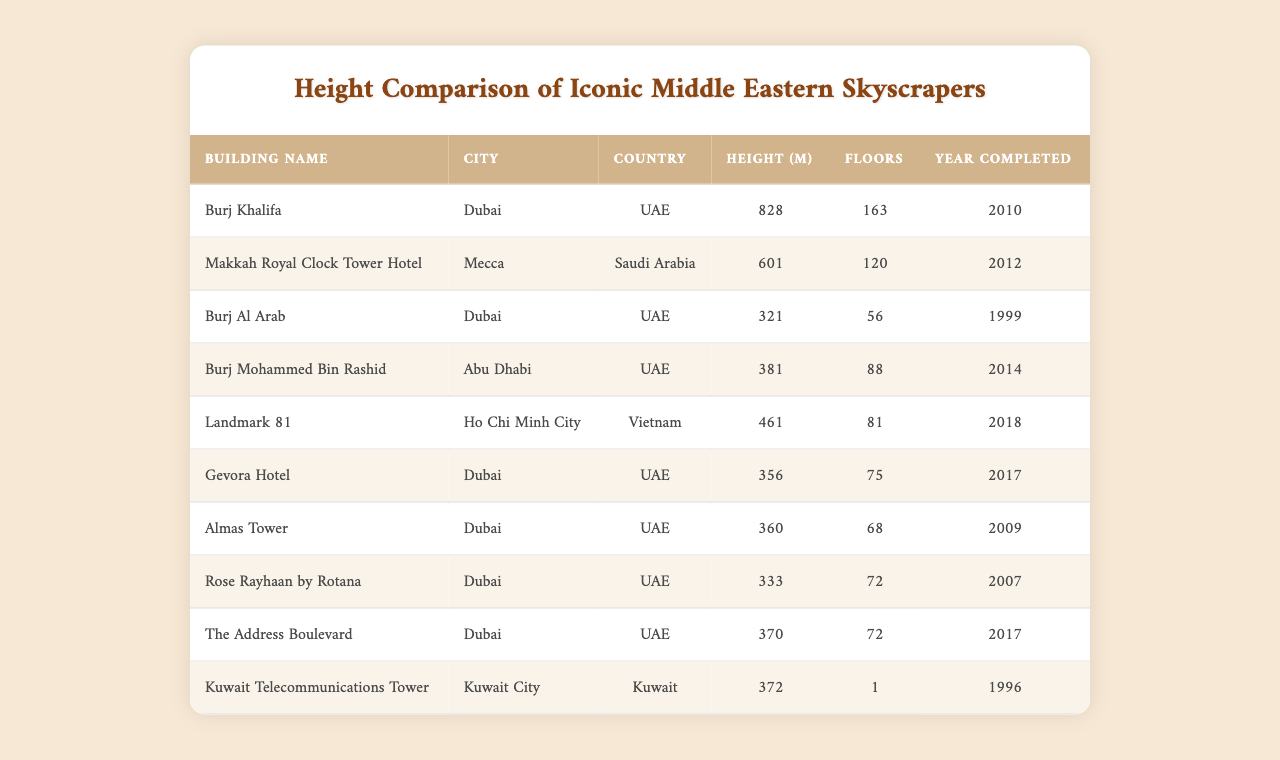What is the tallest skyscraper in the table? The table provides a list of skyscrapers along with their heights. By looking at the 'Height (m)' column, the tallest building, Burj Khalifa, has a height of 828 meters.
Answer: 828 meters How many floors does the Makkah Royal Clock Tower Hotel have? In the row for the Makkah Royal Clock Tower Hotel, the 'Floors' column indicates that it has 120 floors.
Answer: 120 floors Which building is shorter: Burj Al Arab or Gevora Hotel? To compare the heights, Burj Al Arab has a height of 321 meters and Gevora Hotel has 356 meters. Since 321 is less than 356, Burj Al Arab is shorter.
Answer: Burj Al Arab What is the total height of all the skyscrapers listed? We add the heights of all the skyscrapers: 828 + 601 + 321 + 381 + 461 + 356 + 360 + 333 + 370 + 372 = 3,963 meters.
Answer: 3,963 meters Is the Burj Mohammed Bin Rashid taller than the Kuwait Telecommunications Tower? Burj Mohammed Bin Rashid has a height of 381 meters and Kuwait Telecommunications Tower has 372 meters. Since 381 is greater than 372, it is true that Burj Mohammed Bin Rashid is taller.
Answer: Yes What is the average height of the skyscrapers in Dubai listed in the table? The buildings in Dubai and their heights are Burj Khalifa (828), Burj Al Arab (321), Gevora Hotel (356), Almas Tower (360), Rose Rayhaan by Rotana (333), and The Address Boulevard (370). Adding these gives 2,568 meters. There are 6 buildings, so the average height is 2,568 / 6 = 428 meters.
Answer: 428 meters Which city has the highest number of skyscrapers listed? By checking the 'City' column, Dubai has 6 skyscrapers, Mecca has 1, Abu Dhabi has 1, Kuwait City has 1, and Ho Chi Minh City has 1. Thus, Dubai has the highest count of skyscrapers.
Answer: Dubai What is the difference in height between the tallest and the shortest building in the table? The tallest building is Burj Khalifa at 828 meters, and the shortest is Burj Al Arab at 321 meters. Calculating the difference: 828 - 321 = 507 meters.
Answer: 507 meters When was the Burj Al Arab completed? The table shows the 'Year Completed' column, indicating that the Burj Al Arab was completed in 1999.
Answer: 1999 Is any of the skyscrapers completed after 2015? Checking the 'Year Completed' column, the Makkah Royal Clock Tower Hotel (2012), Burj Mohammed Bin Rashid (2014), Gevora Hotel (2017), The Address Boulevard (2017), and Landmark 81 (2018) show some buildings completed after 2015. Therefore, the answer is yes.
Answer: Yes 